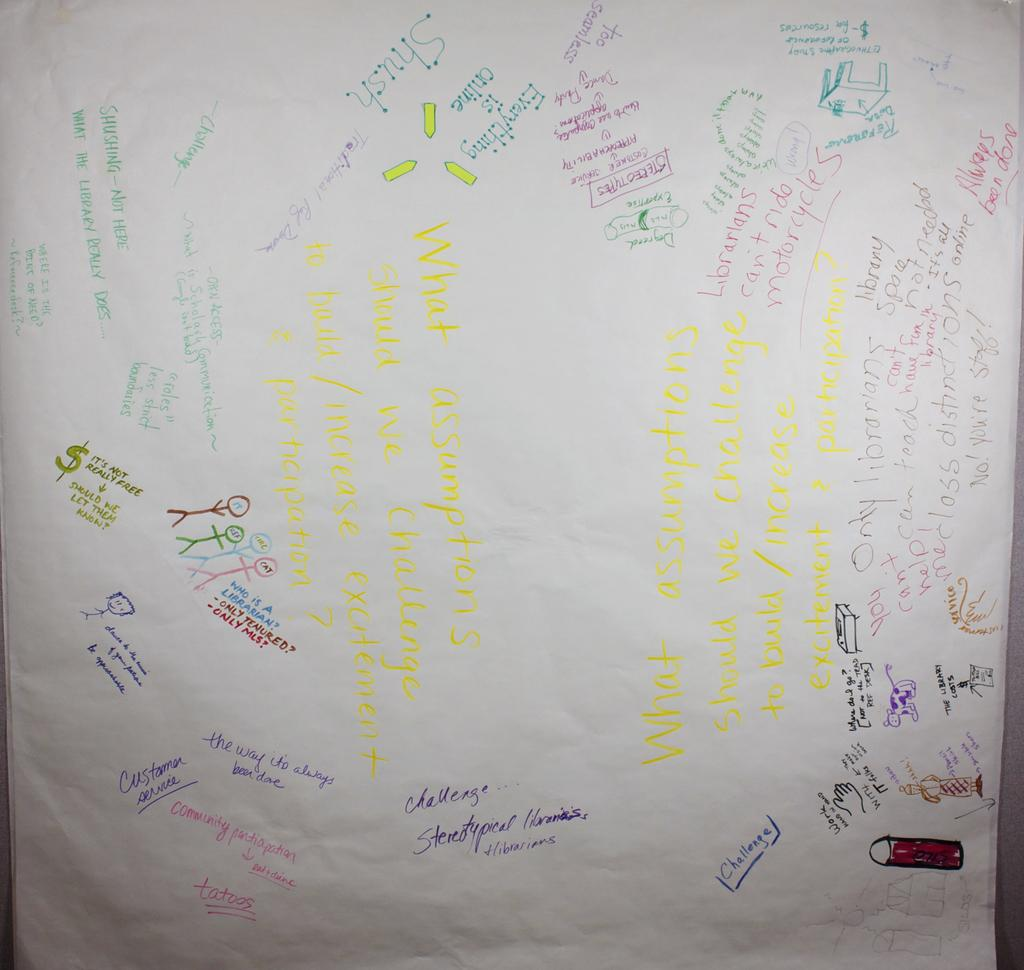<image>
Render a clear and concise summary of the photo. A large white poster paper of phrases such as "the way it's always been done" written on it. 